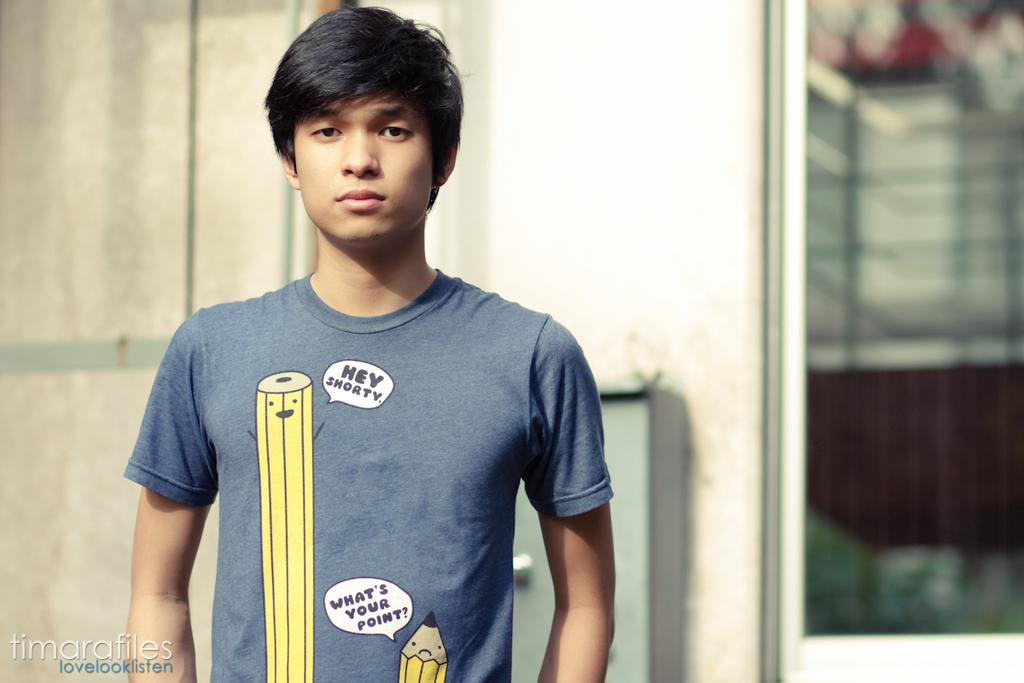<image>
Create a compact narrative representing the image presented. a boy wearing a shirt that says ' hey shorty' and 'what's your point' 